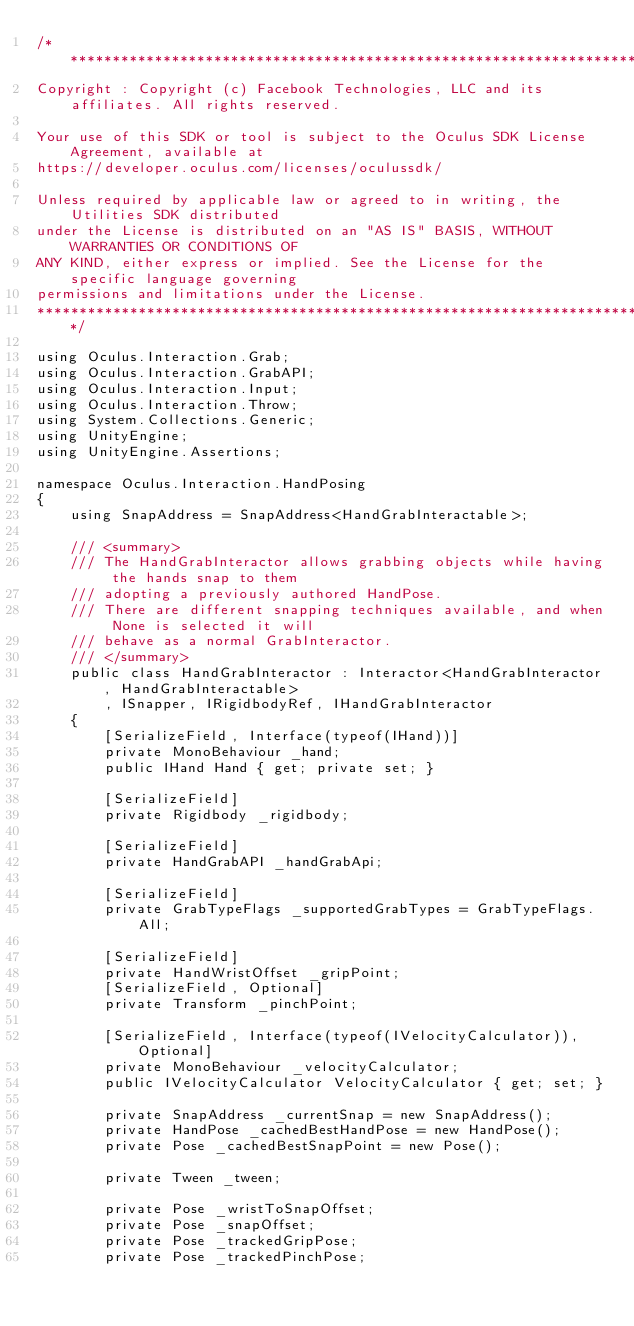Convert code to text. <code><loc_0><loc_0><loc_500><loc_500><_C#_>/************************************************************************************
Copyright : Copyright (c) Facebook Technologies, LLC and its affiliates. All rights reserved.

Your use of this SDK or tool is subject to the Oculus SDK License Agreement, available at
https://developer.oculus.com/licenses/oculussdk/

Unless required by applicable law or agreed to in writing, the Utilities SDK distributed
under the License is distributed on an "AS IS" BASIS, WITHOUT WARRANTIES OR CONDITIONS OF
ANY KIND, either express or implied. See the License for the specific language governing
permissions and limitations under the License.
************************************************************************************/

using Oculus.Interaction.Grab;
using Oculus.Interaction.GrabAPI;
using Oculus.Interaction.Input;
using Oculus.Interaction.Throw;
using System.Collections.Generic;
using UnityEngine;
using UnityEngine.Assertions;

namespace Oculus.Interaction.HandPosing
{
    using SnapAddress = SnapAddress<HandGrabInteractable>;

    /// <summary>
    /// The HandGrabInteractor allows grabbing objects while having the hands snap to them
    /// adopting a previously authored HandPose.
    /// There are different snapping techniques available, and when None is selected it will
    /// behave as a normal GrabInteractor.
    /// </summary>
    public class HandGrabInteractor : Interactor<HandGrabInteractor, HandGrabInteractable>
        , ISnapper, IRigidbodyRef, IHandGrabInteractor
    {
        [SerializeField, Interface(typeof(IHand))]
        private MonoBehaviour _hand;
        public IHand Hand { get; private set; }

        [SerializeField]
        private Rigidbody _rigidbody;

        [SerializeField]
        private HandGrabAPI _handGrabApi;

        [SerializeField]
        private GrabTypeFlags _supportedGrabTypes = GrabTypeFlags.All;

        [SerializeField]
        private HandWristOffset _gripPoint;
        [SerializeField, Optional]
        private Transform _pinchPoint;

        [SerializeField, Interface(typeof(IVelocityCalculator)), Optional]
        private MonoBehaviour _velocityCalculator;
        public IVelocityCalculator VelocityCalculator { get; set; }

        private SnapAddress _currentSnap = new SnapAddress();
        private HandPose _cachedBestHandPose = new HandPose();
        private Pose _cachedBestSnapPoint = new Pose();

        private Tween _tween;

        private Pose _wristToSnapOffset;
        private Pose _snapOffset;
        private Pose _trackedGripPose;
        private Pose _trackedPinchPose;</code> 